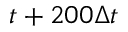Convert formula to latex. <formula><loc_0><loc_0><loc_500><loc_500>t + 2 0 0 \Delta t</formula> 